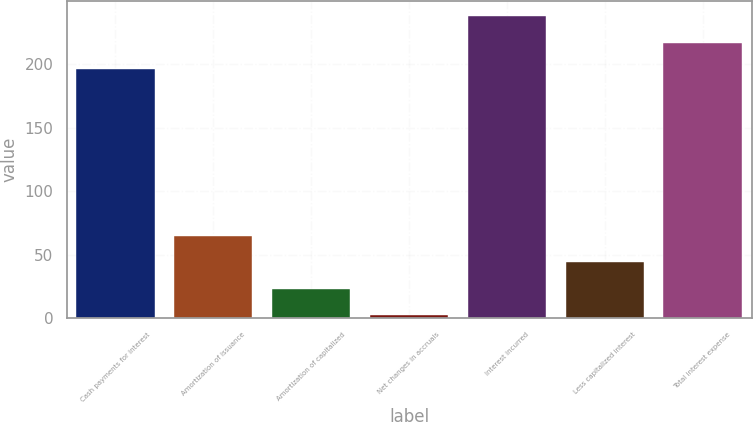Convert chart. <chart><loc_0><loc_0><loc_500><loc_500><bar_chart><fcel>Cash payments for interest<fcel>Amortization of issuance<fcel>Amortization of capitalized<fcel>Net changes in accruals<fcel>Interest incurred<fcel>Less capitalized interest<fcel>Total interest expense<nl><fcel>196<fcel>64.7<fcel>22.9<fcel>2<fcel>237.8<fcel>43.8<fcel>216.9<nl></chart> 